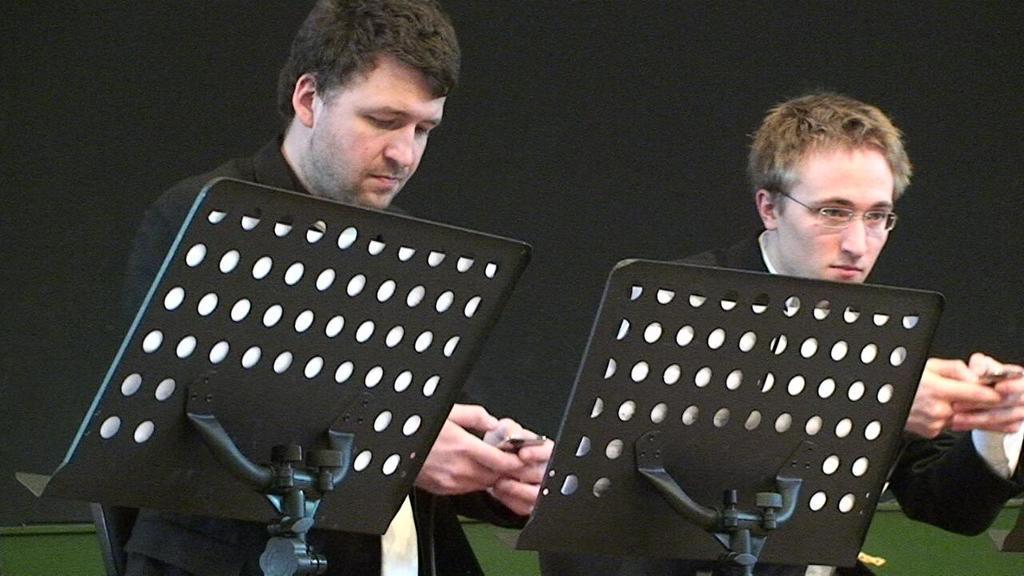Can you describe this image briefly? Background portion of the picture is in white and green color. In this picture we can see men. Among them one wore spectacles and they both are holding objects in their hands. At the bottom portion of the picture we can see the tables and it seems like white papers. 